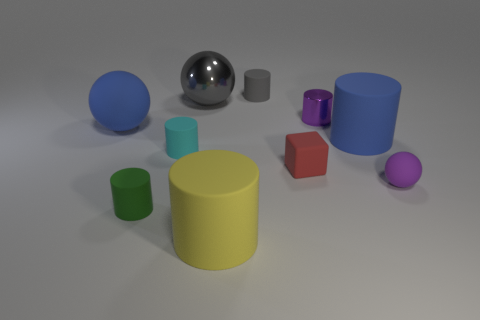Is there a pattern in the arrangement of the objects? There doesn't seem to be a strict pattern in the arrangement of the objects, but they are evenly spaced and neatly laid out across the image. The arrangement appears random yet orderly, with a mix of objects of different sizes, colors, and materials that give the composition a balanced look. 